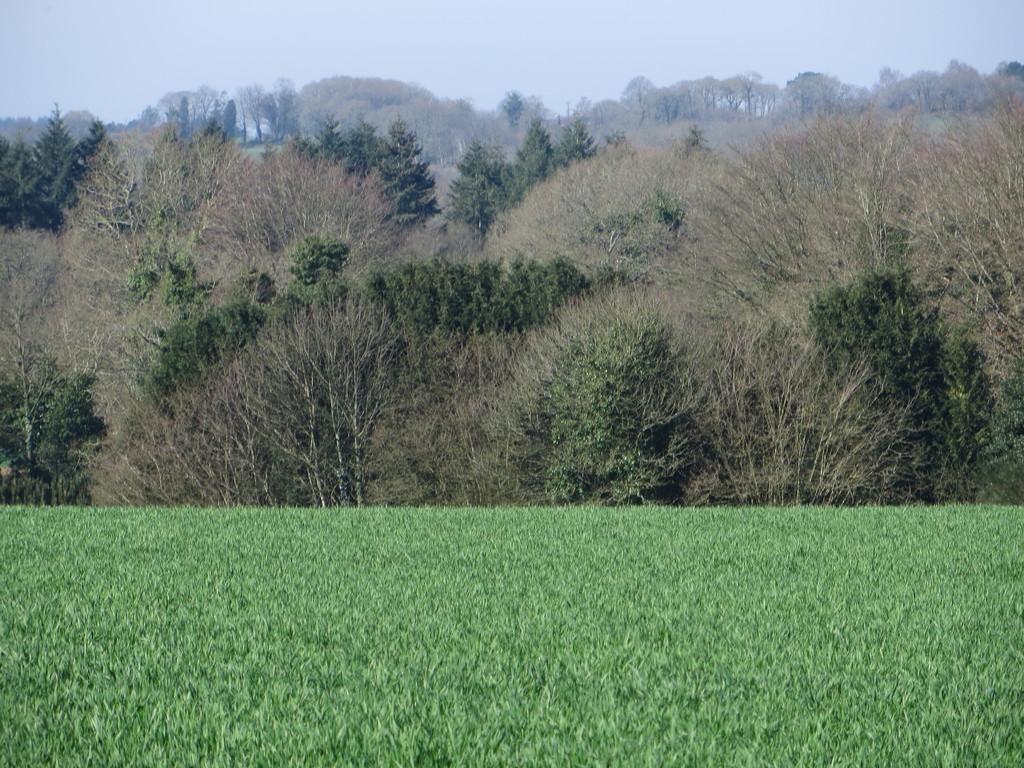Please provide a concise description of this image. In this picture I can see the grass in front and in the background I can see number of trees. On the top of this picture I can see the sky. 